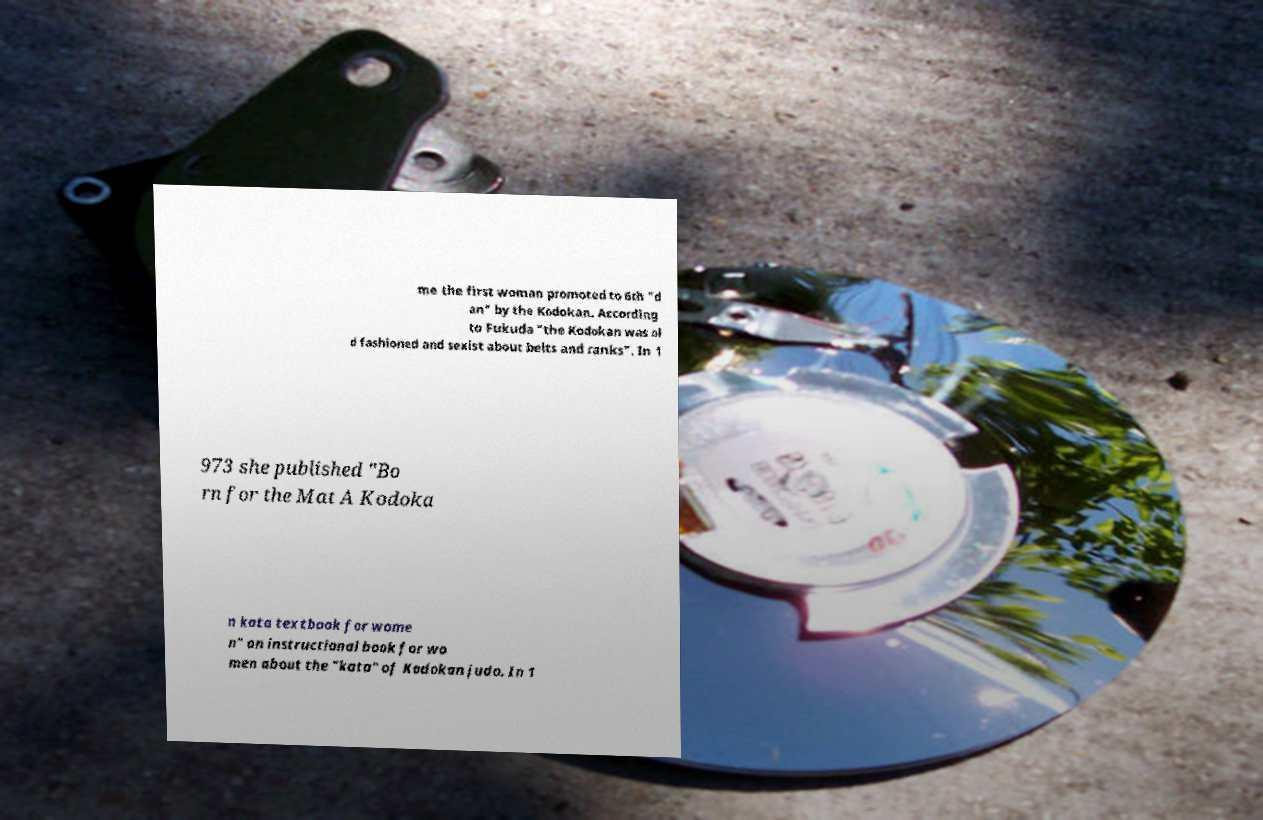Please identify and transcribe the text found in this image. me the first woman promoted to 6th "d an" by the Kodokan. According to Fukuda "the Kodokan was ol d fashioned and sexist about belts and ranks". In 1 973 she published "Bo rn for the Mat A Kodoka n kata textbook for wome n" an instructional book for wo men about the "kata" of Kodokan judo. In 1 